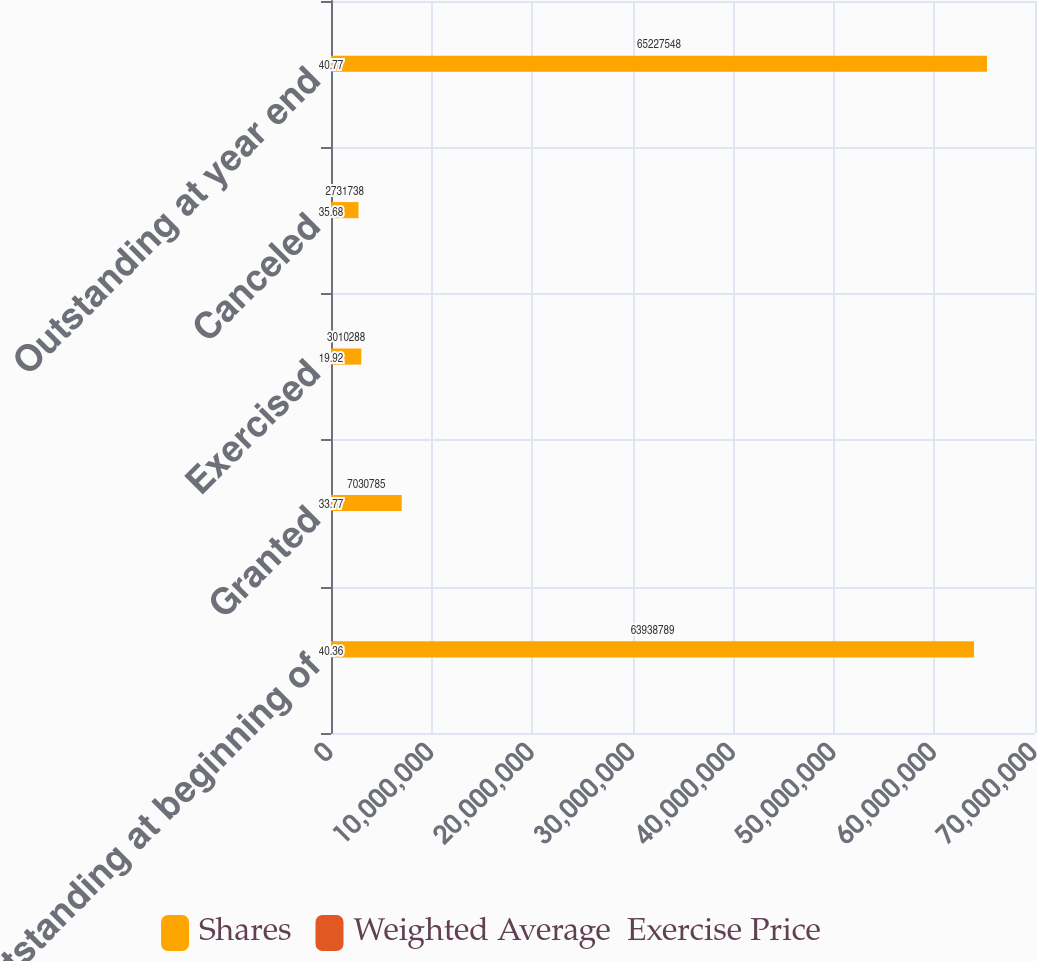Convert chart. <chart><loc_0><loc_0><loc_500><loc_500><stacked_bar_chart><ecel><fcel>Outstanding at beginning of<fcel>Granted<fcel>Exercised<fcel>Canceled<fcel>Outstanding at year end<nl><fcel>Shares<fcel>6.39388e+07<fcel>7.03078e+06<fcel>3.01029e+06<fcel>2.73174e+06<fcel>6.52275e+07<nl><fcel>Weighted Average  Exercise Price<fcel>40.36<fcel>33.77<fcel>19.92<fcel>35.68<fcel>40.77<nl></chart> 